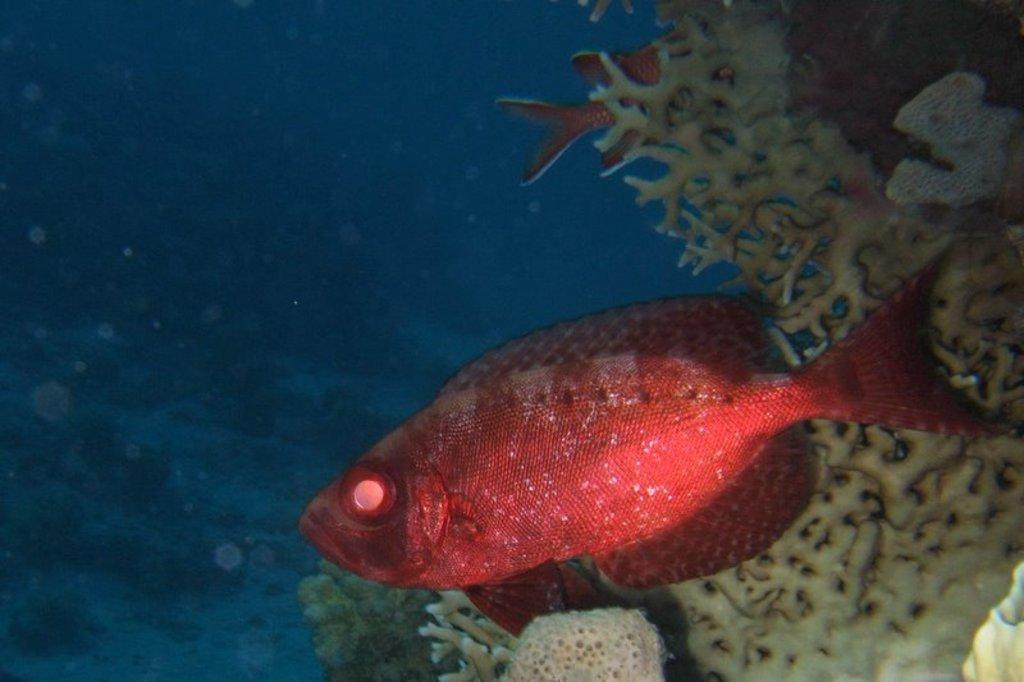What type of animals can be seen in the water in the image? There are fishes in the water in the image. What color are the fishes? The fishes are red in color. What else can be found in the water besides the fishes? There are plants in the water. What type of part can be seen in the image? There is no part visible in the image; it features fishes in the water and plants. How many yams are present in the image? There are no yams present in the image. 